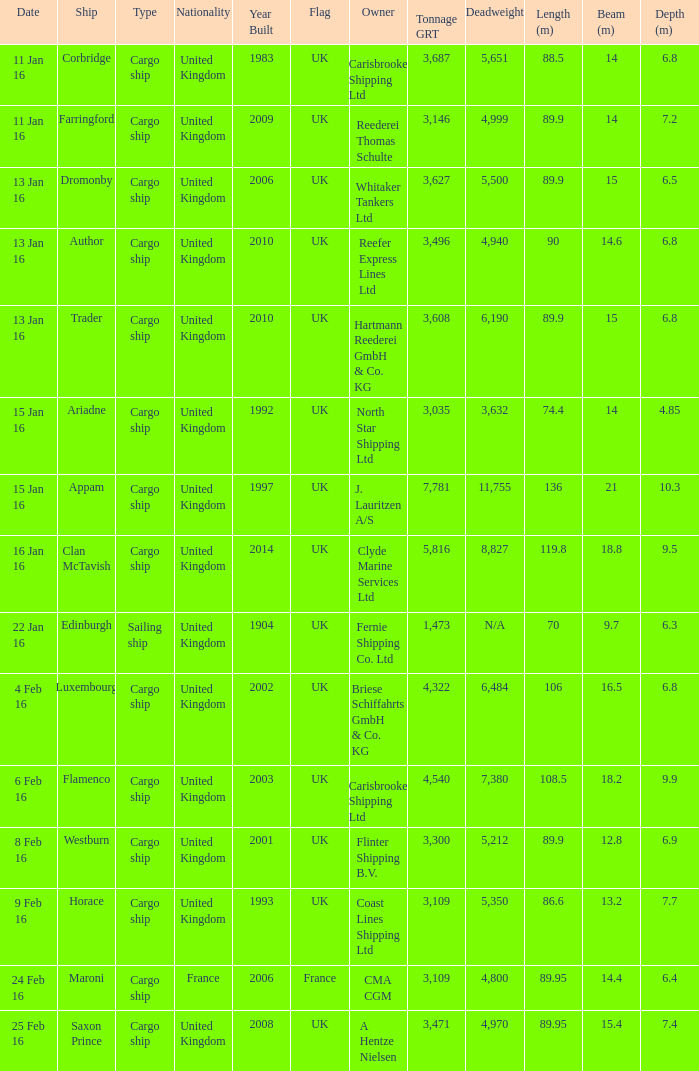What is the nationality of the ship appam? United Kingdom. Give me the full table as a dictionary. {'header': ['Date', 'Ship', 'Type', 'Nationality', 'Year Built', 'Flag', 'Owner', 'Tonnage GRT', 'Deadweight', 'Length (m)', 'Beam (m)', 'Depth (m)'], 'rows': [['11 Jan 16', 'Corbridge', 'Cargo ship', 'United Kingdom', '1983', 'UK', 'Carisbrooke Shipping Ltd', '3,687', '5,651', '88.5', '14', '6.8'], ['11 Jan 16', 'Farringford', 'Cargo ship', 'United Kingdom', '2009', 'UK', 'Reederei Thomas Schulte', '3,146', '4,999', '89.9', '14', '7.2'], ['13 Jan 16', 'Dromonby', 'Cargo ship', 'United Kingdom', '2006', 'UK', 'Whitaker Tankers Ltd', '3,627', '5,500', '89.9', '15', '6.5'], ['13 Jan 16', 'Author', 'Cargo ship', 'United Kingdom', '2010', 'UK', 'Reefer Express Lines Ltd', '3,496', '4,940', '90', '14.6', '6.8'], ['13 Jan 16', 'Trader', 'Cargo ship', 'United Kingdom', '2010', 'UK', 'Hartmann Reederei GmbH & Co. KG', '3,608', '6,190', '89.9', '15', '6.8'], ['15 Jan 16', 'Ariadne', 'Cargo ship', 'United Kingdom', '1992', 'UK', 'North Star Shipping Ltd', '3,035', '3,632', '74.4', '14', '4.85'], ['15 Jan 16', 'Appam', 'Cargo ship', 'United Kingdom', '1997', 'UK', 'J. Lauritzen A/S', '7,781', '11,755', '136', '21', '10.3'], ['16 Jan 16', 'Clan McTavish', 'Cargo ship', 'United Kingdom', '2014', 'UK', 'Clyde Marine Services Ltd', '5,816', '8,827', '119.8', '18.8', '9.5'], ['22 Jan 16', 'Edinburgh', 'Sailing ship', 'United Kingdom', '1904', 'UK', 'Fernie Shipping Co. Ltd', '1,473', 'N/A', '70', '9.7', '6.3'], ['4 Feb 16', 'Luxembourg', 'Cargo ship', 'United Kingdom', '2002', 'UK', 'Briese Schiffahrts GmbH & Co. KG', '4,322', '6,484', '106', '16.5', '6.8'], ['6 Feb 16', 'Flamenco', 'Cargo ship', 'United Kingdom', '2003', 'UK', 'Carisbrooke Shipping Ltd', '4,540', '7,380', '108.5', '18.2', '9.9'], ['8 Feb 16', 'Westburn', 'Cargo ship', 'United Kingdom', '2001', 'UK', 'Flinter Shipping B.V.', '3,300', '5,212', '89.9', '12.8', '6.9'], ['9 Feb 16', 'Horace', 'Cargo ship', 'United Kingdom', '1993', 'UK', 'Coast Lines Shipping Ltd', '3,109', '5,350', '86.6', '13.2', '7.7'], ['24 Feb 16', 'Maroni', 'Cargo ship', 'France', '2006', 'France', 'CMA CGM', '3,109', '4,800', '89.95', '14.4', '6.4'], ['25 Feb 16', 'Saxon Prince', 'Cargo ship', 'United Kingdom', '2008', 'UK', 'A Hentze Nielsen', '3,471', '4,970', '89.95', '15.4', '7.4']]} 